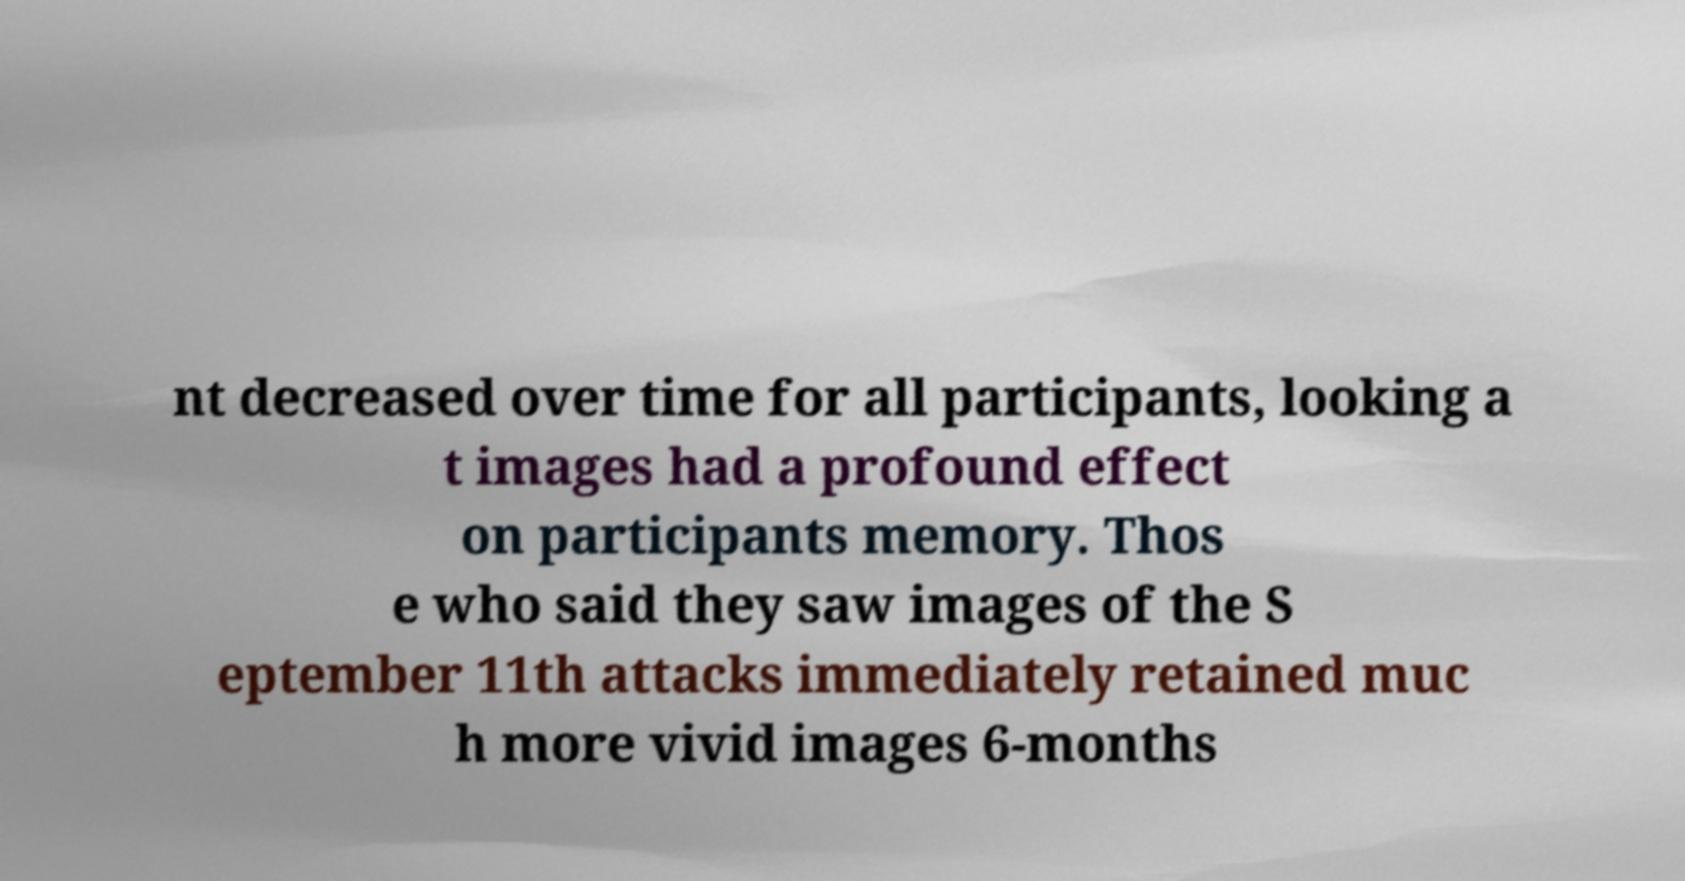Can you read and provide the text displayed in the image?This photo seems to have some interesting text. Can you extract and type it out for me? nt decreased over time for all participants, looking a t images had a profound effect on participants memory. Thos e who said they saw images of the S eptember 11th attacks immediately retained muc h more vivid images 6-months 